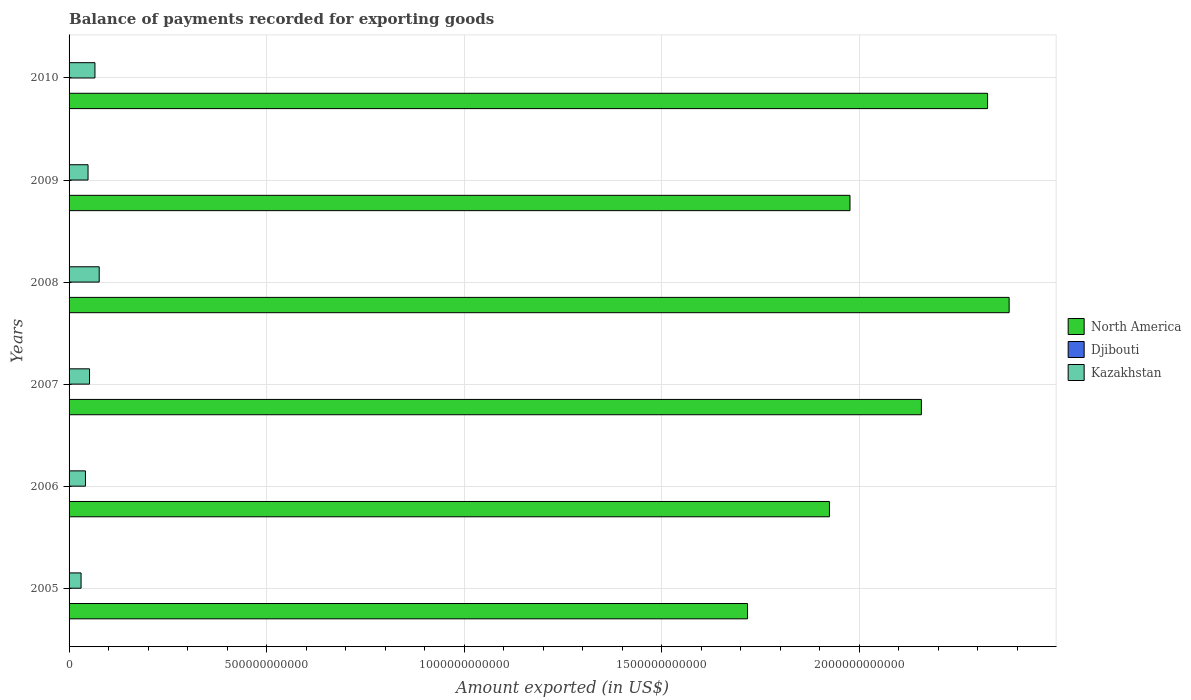How many different coloured bars are there?
Keep it short and to the point. 3. How many groups of bars are there?
Your response must be concise. 6. Are the number of bars on each tick of the Y-axis equal?
Your answer should be very brief. Yes. How many bars are there on the 4th tick from the top?
Your response must be concise. 3. How many bars are there on the 6th tick from the bottom?
Your answer should be compact. 3. What is the label of the 6th group of bars from the top?
Your answer should be very brief. 2005. In how many cases, is the number of bars for a given year not equal to the number of legend labels?
Provide a short and direct response. 0. What is the amount exported in Djibouti in 2006?
Your answer should be compact. 3.07e+08. Across all years, what is the maximum amount exported in North America?
Your answer should be very brief. 2.38e+12. Across all years, what is the minimum amount exported in Djibouti?
Your answer should be compact. 2.88e+08. In which year was the amount exported in Kazakhstan minimum?
Provide a succinct answer. 2005. What is the total amount exported in Djibouti in the graph?
Keep it short and to the point. 2.03e+09. What is the difference between the amount exported in North America in 2008 and that in 2010?
Your answer should be very brief. 5.46e+1. What is the difference between the amount exported in Djibouti in 2006 and the amount exported in North America in 2010?
Offer a very short reply. -2.32e+12. What is the average amount exported in North America per year?
Your answer should be very brief. 2.08e+12. In the year 2007, what is the difference between the amount exported in Kazakhstan and amount exported in North America?
Keep it short and to the point. -2.11e+12. What is the ratio of the amount exported in Kazakhstan in 2006 to that in 2008?
Provide a short and direct response. 0.54. Is the amount exported in North America in 2005 less than that in 2010?
Offer a terse response. Yes. What is the difference between the highest and the second highest amount exported in Kazakhstan?
Your answer should be compact. 1.07e+1. What is the difference between the highest and the lowest amount exported in North America?
Give a very brief answer. 6.62e+11. Is the sum of the amount exported in Kazakhstan in 2007 and 2009 greater than the maximum amount exported in North America across all years?
Provide a succinct answer. No. What does the 1st bar from the top in 2010 represents?
Keep it short and to the point. Kazakhstan. What does the 3rd bar from the bottom in 2008 represents?
Your answer should be compact. Kazakhstan. Is it the case that in every year, the sum of the amount exported in Kazakhstan and amount exported in North America is greater than the amount exported in Djibouti?
Offer a terse response. Yes. Are all the bars in the graph horizontal?
Your answer should be compact. Yes. How many years are there in the graph?
Ensure brevity in your answer.  6. What is the difference between two consecutive major ticks on the X-axis?
Make the answer very short. 5.00e+11. Where does the legend appear in the graph?
Make the answer very short. Center right. How many legend labels are there?
Keep it short and to the point. 3. What is the title of the graph?
Offer a terse response. Balance of payments recorded for exporting goods. Does "Other small states" appear as one of the legend labels in the graph?
Ensure brevity in your answer.  No. What is the label or title of the X-axis?
Make the answer very short. Amount exported (in US$). What is the label or title of the Y-axis?
Provide a short and direct response. Years. What is the Amount exported (in US$) of North America in 2005?
Keep it short and to the point. 1.72e+12. What is the Amount exported (in US$) in Djibouti in 2005?
Offer a very short reply. 2.88e+08. What is the Amount exported (in US$) of Kazakhstan in 2005?
Offer a very short reply. 3.04e+1. What is the Amount exported (in US$) of North America in 2006?
Your response must be concise. 1.92e+12. What is the Amount exported (in US$) in Djibouti in 2006?
Make the answer very short. 3.07e+08. What is the Amount exported (in US$) in Kazakhstan in 2006?
Give a very brief answer. 4.14e+1. What is the Amount exported (in US$) in North America in 2007?
Provide a succinct answer. 2.16e+12. What is the Amount exported (in US$) in Djibouti in 2007?
Your response must be concise. 2.94e+08. What is the Amount exported (in US$) in Kazakhstan in 2007?
Provide a short and direct response. 5.18e+1. What is the Amount exported (in US$) in North America in 2008?
Offer a terse response. 2.38e+12. What is the Amount exported (in US$) in Djibouti in 2008?
Keep it short and to the point. 3.53e+08. What is the Amount exported (in US$) in Kazakhstan in 2008?
Offer a very short reply. 7.63e+1. What is the Amount exported (in US$) in North America in 2009?
Your response must be concise. 1.98e+12. What is the Amount exported (in US$) of Djibouti in 2009?
Offer a very short reply. 3.86e+08. What is the Amount exported (in US$) in Kazakhstan in 2009?
Your response must be concise. 4.80e+1. What is the Amount exported (in US$) in North America in 2010?
Make the answer very short. 2.32e+12. What is the Amount exported (in US$) of Djibouti in 2010?
Make the answer very short. 4.06e+08. What is the Amount exported (in US$) of Kazakhstan in 2010?
Your answer should be compact. 6.55e+1. Across all years, what is the maximum Amount exported (in US$) of North America?
Keep it short and to the point. 2.38e+12. Across all years, what is the maximum Amount exported (in US$) of Djibouti?
Your response must be concise. 4.06e+08. Across all years, what is the maximum Amount exported (in US$) in Kazakhstan?
Give a very brief answer. 7.63e+1. Across all years, what is the minimum Amount exported (in US$) in North America?
Make the answer very short. 1.72e+12. Across all years, what is the minimum Amount exported (in US$) of Djibouti?
Offer a terse response. 2.88e+08. Across all years, what is the minimum Amount exported (in US$) of Kazakhstan?
Your response must be concise. 3.04e+1. What is the total Amount exported (in US$) in North America in the graph?
Provide a short and direct response. 1.25e+13. What is the total Amount exported (in US$) in Djibouti in the graph?
Your answer should be compact. 2.03e+09. What is the total Amount exported (in US$) in Kazakhstan in the graph?
Ensure brevity in your answer.  3.13e+11. What is the difference between the Amount exported (in US$) in North America in 2005 and that in 2006?
Your answer should be very brief. -2.07e+11. What is the difference between the Amount exported (in US$) in Djibouti in 2005 and that in 2006?
Your response must be concise. -1.88e+07. What is the difference between the Amount exported (in US$) of Kazakhstan in 2005 and that in 2006?
Give a very brief answer. -1.11e+1. What is the difference between the Amount exported (in US$) of North America in 2005 and that in 2007?
Make the answer very short. -4.40e+11. What is the difference between the Amount exported (in US$) of Djibouti in 2005 and that in 2007?
Provide a succinct answer. -6.30e+06. What is the difference between the Amount exported (in US$) in Kazakhstan in 2005 and that in 2007?
Make the answer very short. -2.14e+1. What is the difference between the Amount exported (in US$) of North America in 2005 and that in 2008?
Your answer should be compact. -6.62e+11. What is the difference between the Amount exported (in US$) in Djibouti in 2005 and that in 2008?
Give a very brief answer. -6.48e+07. What is the difference between the Amount exported (in US$) of Kazakhstan in 2005 and that in 2008?
Offer a very short reply. -4.59e+1. What is the difference between the Amount exported (in US$) in North America in 2005 and that in 2009?
Ensure brevity in your answer.  -2.59e+11. What is the difference between the Amount exported (in US$) of Djibouti in 2005 and that in 2009?
Give a very brief answer. -9.79e+07. What is the difference between the Amount exported (in US$) in Kazakhstan in 2005 and that in 2009?
Make the answer very short. -1.76e+1. What is the difference between the Amount exported (in US$) in North America in 2005 and that in 2010?
Your response must be concise. -6.07e+11. What is the difference between the Amount exported (in US$) in Djibouti in 2005 and that in 2010?
Ensure brevity in your answer.  -1.18e+08. What is the difference between the Amount exported (in US$) in Kazakhstan in 2005 and that in 2010?
Offer a very short reply. -3.51e+1. What is the difference between the Amount exported (in US$) in North America in 2006 and that in 2007?
Provide a succinct answer. -2.33e+11. What is the difference between the Amount exported (in US$) in Djibouti in 2006 and that in 2007?
Ensure brevity in your answer.  1.25e+07. What is the difference between the Amount exported (in US$) of Kazakhstan in 2006 and that in 2007?
Provide a succinct answer. -1.03e+1. What is the difference between the Amount exported (in US$) of North America in 2006 and that in 2008?
Your answer should be very brief. -4.55e+11. What is the difference between the Amount exported (in US$) of Djibouti in 2006 and that in 2008?
Ensure brevity in your answer.  -4.61e+07. What is the difference between the Amount exported (in US$) in Kazakhstan in 2006 and that in 2008?
Provide a short and direct response. -3.48e+1. What is the difference between the Amount exported (in US$) in North America in 2006 and that in 2009?
Keep it short and to the point. -5.20e+1. What is the difference between the Amount exported (in US$) of Djibouti in 2006 and that in 2009?
Your answer should be compact. -7.92e+07. What is the difference between the Amount exported (in US$) in Kazakhstan in 2006 and that in 2009?
Your response must be concise. -6.59e+09. What is the difference between the Amount exported (in US$) in North America in 2006 and that in 2010?
Offer a terse response. -4.00e+11. What is the difference between the Amount exported (in US$) of Djibouti in 2006 and that in 2010?
Make the answer very short. -9.96e+07. What is the difference between the Amount exported (in US$) of Kazakhstan in 2006 and that in 2010?
Provide a succinct answer. -2.41e+1. What is the difference between the Amount exported (in US$) of North America in 2007 and that in 2008?
Ensure brevity in your answer.  -2.22e+11. What is the difference between the Amount exported (in US$) of Djibouti in 2007 and that in 2008?
Your response must be concise. -5.85e+07. What is the difference between the Amount exported (in US$) in Kazakhstan in 2007 and that in 2008?
Your answer should be compact. -2.45e+1. What is the difference between the Amount exported (in US$) of North America in 2007 and that in 2009?
Your response must be concise. 1.81e+11. What is the difference between the Amount exported (in US$) in Djibouti in 2007 and that in 2009?
Provide a succinct answer. -9.16e+07. What is the difference between the Amount exported (in US$) in Kazakhstan in 2007 and that in 2009?
Keep it short and to the point. 3.75e+09. What is the difference between the Amount exported (in US$) in North America in 2007 and that in 2010?
Your response must be concise. -1.67e+11. What is the difference between the Amount exported (in US$) in Djibouti in 2007 and that in 2010?
Offer a very short reply. -1.12e+08. What is the difference between the Amount exported (in US$) in Kazakhstan in 2007 and that in 2010?
Offer a very short reply. -1.37e+1. What is the difference between the Amount exported (in US$) of North America in 2008 and that in 2009?
Your answer should be compact. 4.03e+11. What is the difference between the Amount exported (in US$) in Djibouti in 2008 and that in 2009?
Provide a succinct answer. -3.31e+07. What is the difference between the Amount exported (in US$) of Kazakhstan in 2008 and that in 2009?
Your answer should be very brief. 2.82e+1. What is the difference between the Amount exported (in US$) in North America in 2008 and that in 2010?
Make the answer very short. 5.46e+1. What is the difference between the Amount exported (in US$) in Djibouti in 2008 and that in 2010?
Ensure brevity in your answer.  -5.36e+07. What is the difference between the Amount exported (in US$) of Kazakhstan in 2008 and that in 2010?
Provide a succinct answer. 1.07e+1. What is the difference between the Amount exported (in US$) in North America in 2009 and that in 2010?
Your response must be concise. -3.48e+11. What is the difference between the Amount exported (in US$) in Djibouti in 2009 and that in 2010?
Your answer should be compact. -2.05e+07. What is the difference between the Amount exported (in US$) of Kazakhstan in 2009 and that in 2010?
Offer a terse response. -1.75e+1. What is the difference between the Amount exported (in US$) in North America in 2005 and the Amount exported (in US$) in Djibouti in 2006?
Ensure brevity in your answer.  1.72e+12. What is the difference between the Amount exported (in US$) in North America in 2005 and the Amount exported (in US$) in Kazakhstan in 2006?
Provide a succinct answer. 1.68e+12. What is the difference between the Amount exported (in US$) in Djibouti in 2005 and the Amount exported (in US$) in Kazakhstan in 2006?
Offer a very short reply. -4.12e+1. What is the difference between the Amount exported (in US$) of North America in 2005 and the Amount exported (in US$) of Djibouti in 2007?
Offer a terse response. 1.72e+12. What is the difference between the Amount exported (in US$) in North America in 2005 and the Amount exported (in US$) in Kazakhstan in 2007?
Your answer should be compact. 1.67e+12. What is the difference between the Amount exported (in US$) of Djibouti in 2005 and the Amount exported (in US$) of Kazakhstan in 2007?
Give a very brief answer. -5.15e+1. What is the difference between the Amount exported (in US$) of North America in 2005 and the Amount exported (in US$) of Djibouti in 2008?
Offer a very short reply. 1.72e+12. What is the difference between the Amount exported (in US$) in North America in 2005 and the Amount exported (in US$) in Kazakhstan in 2008?
Provide a short and direct response. 1.64e+12. What is the difference between the Amount exported (in US$) of Djibouti in 2005 and the Amount exported (in US$) of Kazakhstan in 2008?
Your response must be concise. -7.60e+1. What is the difference between the Amount exported (in US$) of North America in 2005 and the Amount exported (in US$) of Djibouti in 2009?
Your answer should be very brief. 1.72e+12. What is the difference between the Amount exported (in US$) of North America in 2005 and the Amount exported (in US$) of Kazakhstan in 2009?
Provide a succinct answer. 1.67e+12. What is the difference between the Amount exported (in US$) in Djibouti in 2005 and the Amount exported (in US$) in Kazakhstan in 2009?
Keep it short and to the point. -4.77e+1. What is the difference between the Amount exported (in US$) in North America in 2005 and the Amount exported (in US$) in Djibouti in 2010?
Keep it short and to the point. 1.72e+12. What is the difference between the Amount exported (in US$) in North America in 2005 and the Amount exported (in US$) in Kazakhstan in 2010?
Ensure brevity in your answer.  1.65e+12. What is the difference between the Amount exported (in US$) of Djibouti in 2005 and the Amount exported (in US$) of Kazakhstan in 2010?
Offer a terse response. -6.52e+1. What is the difference between the Amount exported (in US$) of North America in 2006 and the Amount exported (in US$) of Djibouti in 2007?
Your response must be concise. 1.92e+12. What is the difference between the Amount exported (in US$) in North America in 2006 and the Amount exported (in US$) in Kazakhstan in 2007?
Ensure brevity in your answer.  1.87e+12. What is the difference between the Amount exported (in US$) in Djibouti in 2006 and the Amount exported (in US$) in Kazakhstan in 2007?
Ensure brevity in your answer.  -5.15e+1. What is the difference between the Amount exported (in US$) of North America in 2006 and the Amount exported (in US$) of Djibouti in 2008?
Your response must be concise. 1.92e+12. What is the difference between the Amount exported (in US$) in North America in 2006 and the Amount exported (in US$) in Kazakhstan in 2008?
Your answer should be compact. 1.85e+12. What is the difference between the Amount exported (in US$) of Djibouti in 2006 and the Amount exported (in US$) of Kazakhstan in 2008?
Provide a short and direct response. -7.59e+1. What is the difference between the Amount exported (in US$) in North America in 2006 and the Amount exported (in US$) in Djibouti in 2009?
Offer a terse response. 1.92e+12. What is the difference between the Amount exported (in US$) of North America in 2006 and the Amount exported (in US$) of Kazakhstan in 2009?
Offer a terse response. 1.88e+12. What is the difference between the Amount exported (in US$) of Djibouti in 2006 and the Amount exported (in US$) of Kazakhstan in 2009?
Offer a terse response. -4.77e+1. What is the difference between the Amount exported (in US$) in North America in 2006 and the Amount exported (in US$) in Djibouti in 2010?
Provide a short and direct response. 1.92e+12. What is the difference between the Amount exported (in US$) of North America in 2006 and the Amount exported (in US$) of Kazakhstan in 2010?
Ensure brevity in your answer.  1.86e+12. What is the difference between the Amount exported (in US$) in Djibouti in 2006 and the Amount exported (in US$) in Kazakhstan in 2010?
Offer a terse response. -6.52e+1. What is the difference between the Amount exported (in US$) of North America in 2007 and the Amount exported (in US$) of Djibouti in 2008?
Ensure brevity in your answer.  2.16e+12. What is the difference between the Amount exported (in US$) in North America in 2007 and the Amount exported (in US$) in Kazakhstan in 2008?
Your response must be concise. 2.08e+12. What is the difference between the Amount exported (in US$) of Djibouti in 2007 and the Amount exported (in US$) of Kazakhstan in 2008?
Keep it short and to the point. -7.60e+1. What is the difference between the Amount exported (in US$) in North America in 2007 and the Amount exported (in US$) in Djibouti in 2009?
Offer a very short reply. 2.16e+12. What is the difference between the Amount exported (in US$) of North America in 2007 and the Amount exported (in US$) of Kazakhstan in 2009?
Keep it short and to the point. 2.11e+12. What is the difference between the Amount exported (in US$) in Djibouti in 2007 and the Amount exported (in US$) in Kazakhstan in 2009?
Ensure brevity in your answer.  -4.77e+1. What is the difference between the Amount exported (in US$) of North America in 2007 and the Amount exported (in US$) of Djibouti in 2010?
Offer a very short reply. 2.16e+12. What is the difference between the Amount exported (in US$) of North America in 2007 and the Amount exported (in US$) of Kazakhstan in 2010?
Your answer should be compact. 2.09e+12. What is the difference between the Amount exported (in US$) of Djibouti in 2007 and the Amount exported (in US$) of Kazakhstan in 2010?
Ensure brevity in your answer.  -6.52e+1. What is the difference between the Amount exported (in US$) in North America in 2008 and the Amount exported (in US$) in Djibouti in 2009?
Give a very brief answer. 2.38e+12. What is the difference between the Amount exported (in US$) of North America in 2008 and the Amount exported (in US$) of Kazakhstan in 2009?
Offer a terse response. 2.33e+12. What is the difference between the Amount exported (in US$) of Djibouti in 2008 and the Amount exported (in US$) of Kazakhstan in 2009?
Your response must be concise. -4.77e+1. What is the difference between the Amount exported (in US$) of North America in 2008 and the Amount exported (in US$) of Djibouti in 2010?
Keep it short and to the point. 2.38e+12. What is the difference between the Amount exported (in US$) in North America in 2008 and the Amount exported (in US$) in Kazakhstan in 2010?
Provide a succinct answer. 2.31e+12. What is the difference between the Amount exported (in US$) of Djibouti in 2008 and the Amount exported (in US$) of Kazakhstan in 2010?
Make the answer very short. -6.52e+1. What is the difference between the Amount exported (in US$) of North America in 2009 and the Amount exported (in US$) of Djibouti in 2010?
Provide a succinct answer. 1.98e+12. What is the difference between the Amount exported (in US$) in North America in 2009 and the Amount exported (in US$) in Kazakhstan in 2010?
Provide a succinct answer. 1.91e+12. What is the difference between the Amount exported (in US$) in Djibouti in 2009 and the Amount exported (in US$) in Kazakhstan in 2010?
Offer a very short reply. -6.51e+1. What is the average Amount exported (in US$) in North America per year?
Make the answer very short. 2.08e+12. What is the average Amount exported (in US$) of Djibouti per year?
Keep it short and to the point. 3.39e+08. What is the average Amount exported (in US$) of Kazakhstan per year?
Make the answer very short. 5.22e+1. In the year 2005, what is the difference between the Amount exported (in US$) of North America and Amount exported (in US$) of Djibouti?
Your answer should be very brief. 1.72e+12. In the year 2005, what is the difference between the Amount exported (in US$) of North America and Amount exported (in US$) of Kazakhstan?
Your answer should be compact. 1.69e+12. In the year 2005, what is the difference between the Amount exported (in US$) in Djibouti and Amount exported (in US$) in Kazakhstan?
Your answer should be very brief. -3.01e+1. In the year 2006, what is the difference between the Amount exported (in US$) in North America and Amount exported (in US$) in Djibouti?
Your answer should be compact. 1.92e+12. In the year 2006, what is the difference between the Amount exported (in US$) of North America and Amount exported (in US$) of Kazakhstan?
Offer a very short reply. 1.88e+12. In the year 2006, what is the difference between the Amount exported (in US$) of Djibouti and Amount exported (in US$) of Kazakhstan?
Offer a terse response. -4.11e+1. In the year 2007, what is the difference between the Amount exported (in US$) in North America and Amount exported (in US$) in Djibouti?
Your response must be concise. 2.16e+12. In the year 2007, what is the difference between the Amount exported (in US$) of North America and Amount exported (in US$) of Kazakhstan?
Give a very brief answer. 2.11e+12. In the year 2007, what is the difference between the Amount exported (in US$) of Djibouti and Amount exported (in US$) of Kazakhstan?
Your answer should be compact. -5.15e+1. In the year 2008, what is the difference between the Amount exported (in US$) of North America and Amount exported (in US$) of Djibouti?
Offer a very short reply. 2.38e+12. In the year 2008, what is the difference between the Amount exported (in US$) of North America and Amount exported (in US$) of Kazakhstan?
Your response must be concise. 2.30e+12. In the year 2008, what is the difference between the Amount exported (in US$) in Djibouti and Amount exported (in US$) in Kazakhstan?
Provide a succinct answer. -7.59e+1. In the year 2009, what is the difference between the Amount exported (in US$) of North America and Amount exported (in US$) of Djibouti?
Ensure brevity in your answer.  1.98e+12. In the year 2009, what is the difference between the Amount exported (in US$) in North America and Amount exported (in US$) in Kazakhstan?
Your answer should be compact. 1.93e+12. In the year 2009, what is the difference between the Amount exported (in US$) of Djibouti and Amount exported (in US$) of Kazakhstan?
Offer a terse response. -4.76e+1. In the year 2010, what is the difference between the Amount exported (in US$) of North America and Amount exported (in US$) of Djibouti?
Offer a terse response. 2.32e+12. In the year 2010, what is the difference between the Amount exported (in US$) of North America and Amount exported (in US$) of Kazakhstan?
Keep it short and to the point. 2.26e+12. In the year 2010, what is the difference between the Amount exported (in US$) of Djibouti and Amount exported (in US$) of Kazakhstan?
Offer a terse response. -6.51e+1. What is the ratio of the Amount exported (in US$) in North America in 2005 to that in 2006?
Make the answer very short. 0.89. What is the ratio of the Amount exported (in US$) in Djibouti in 2005 to that in 2006?
Your answer should be very brief. 0.94. What is the ratio of the Amount exported (in US$) in Kazakhstan in 2005 to that in 2006?
Give a very brief answer. 0.73. What is the ratio of the Amount exported (in US$) of North America in 2005 to that in 2007?
Offer a terse response. 0.8. What is the ratio of the Amount exported (in US$) in Djibouti in 2005 to that in 2007?
Offer a very short reply. 0.98. What is the ratio of the Amount exported (in US$) in Kazakhstan in 2005 to that in 2007?
Provide a short and direct response. 0.59. What is the ratio of the Amount exported (in US$) in North America in 2005 to that in 2008?
Keep it short and to the point. 0.72. What is the ratio of the Amount exported (in US$) in Djibouti in 2005 to that in 2008?
Your answer should be very brief. 0.82. What is the ratio of the Amount exported (in US$) of Kazakhstan in 2005 to that in 2008?
Provide a succinct answer. 0.4. What is the ratio of the Amount exported (in US$) in North America in 2005 to that in 2009?
Provide a succinct answer. 0.87. What is the ratio of the Amount exported (in US$) of Djibouti in 2005 to that in 2009?
Give a very brief answer. 0.75. What is the ratio of the Amount exported (in US$) of Kazakhstan in 2005 to that in 2009?
Give a very brief answer. 0.63. What is the ratio of the Amount exported (in US$) in North America in 2005 to that in 2010?
Make the answer very short. 0.74. What is the ratio of the Amount exported (in US$) in Djibouti in 2005 to that in 2010?
Give a very brief answer. 0.71. What is the ratio of the Amount exported (in US$) in Kazakhstan in 2005 to that in 2010?
Offer a very short reply. 0.46. What is the ratio of the Amount exported (in US$) of North America in 2006 to that in 2007?
Provide a succinct answer. 0.89. What is the ratio of the Amount exported (in US$) of Djibouti in 2006 to that in 2007?
Give a very brief answer. 1.04. What is the ratio of the Amount exported (in US$) of Kazakhstan in 2006 to that in 2007?
Give a very brief answer. 0.8. What is the ratio of the Amount exported (in US$) of North America in 2006 to that in 2008?
Keep it short and to the point. 0.81. What is the ratio of the Amount exported (in US$) in Djibouti in 2006 to that in 2008?
Keep it short and to the point. 0.87. What is the ratio of the Amount exported (in US$) in Kazakhstan in 2006 to that in 2008?
Offer a very short reply. 0.54. What is the ratio of the Amount exported (in US$) of North America in 2006 to that in 2009?
Make the answer very short. 0.97. What is the ratio of the Amount exported (in US$) of Djibouti in 2006 to that in 2009?
Ensure brevity in your answer.  0.79. What is the ratio of the Amount exported (in US$) of Kazakhstan in 2006 to that in 2009?
Provide a short and direct response. 0.86. What is the ratio of the Amount exported (in US$) in North America in 2006 to that in 2010?
Offer a very short reply. 0.83. What is the ratio of the Amount exported (in US$) of Djibouti in 2006 to that in 2010?
Offer a terse response. 0.75. What is the ratio of the Amount exported (in US$) in Kazakhstan in 2006 to that in 2010?
Give a very brief answer. 0.63. What is the ratio of the Amount exported (in US$) of North America in 2007 to that in 2008?
Make the answer very short. 0.91. What is the ratio of the Amount exported (in US$) in Djibouti in 2007 to that in 2008?
Ensure brevity in your answer.  0.83. What is the ratio of the Amount exported (in US$) of Kazakhstan in 2007 to that in 2008?
Offer a very short reply. 0.68. What is the ratio of the Amount exported (in US$) in North America in 2007 to that in 2009?
Keep it short and to the point. 1.09. What is the ratio of the Amount exported (in US$) in Djibouti in 2007 to that in 2009?
Offer a very short reply. 0.76. What is the ratio of the Amount exported (in US$) in Kazakhstan in 2007 to that in 2009?
Offer a very short reply. 1.08. What is the ratio of the Amount exported (in US$) in North America in 2007 to that in 2010?
Provide a succinct answer. 0.93. What is the ratio of the Amount exported (in US$) in Djibouti in 2007 to that in 2010?
Offer a very short reply. 0.72. What is the ratio of the Amount exported (in US$) of Kazakhstan in 2007 to that in 2010?
Make the answer very short. 0.79. What is the ratio of the Amount exported (in US$) in North America in 2008 to that in 2009?
Make the answer very short. 1.2. What is the ratio of the Amount exported (in US$) in Djibouti in 2008 to that in 2009?
Offer a very short reply. 0.91. What is the ratio of the Amount exported (in US$) in Kazakhstan in 2008 to that in 2009?
Ensure brevity in your answer.  1.59. What is the ratio of the Amount exported (in US$) in North America in 2008 to that in 2010?
Give a very brief answer. 1.02. What is the ratio of the Amount exported (in US$) in Djibouti in 2008 to that in 2010?
Offer a terse response. 0.87. What is the ratio of the Amount exported (in US$) of Kazakhstan in 2008 to that in 2010?
Your answer should be very brief. 1.16. What is the ratio of the Amount exported (in US$) of North America in 2009 to that in 2010?
Offer a terse response. 0.85. What is the ratio of the Amount exported (in US$) of Djibouti in 2009 to that in 2010?
Your answer should be very brief. 0.95. What is the ratio of the Amount exported (in US$) of Kazakhstan in 2009 to that in 2010?
Give a very brief answer. 0.73. What is the difference between the highest and the second highest Amount exported (in US$) of North America?
Make the answer very short. 5.46e+1. What is the difference between the highest and the second highest Amount exported (in US$) of Djibouti?
Your answer should be very brief. 2.05e+07. What is the difference between the highest and the second highest Amount exported (in US$) in Kazakhstan?
Provide a short and direct response. 1.07e+1. What is the difference between the highest and the lowest Amount exported (in US$) of North America?
Keep it short and to the point. 6.62e+11. What is the difference between the highest and the lowest Amount exported (in US$) in Djibouti?
Make the answer very short. 1.18e+08. What is the difference between the highest and the lowest Amount exported (in US$) in Kazakhstan?
Make the answer very short. 4.59e+1. 